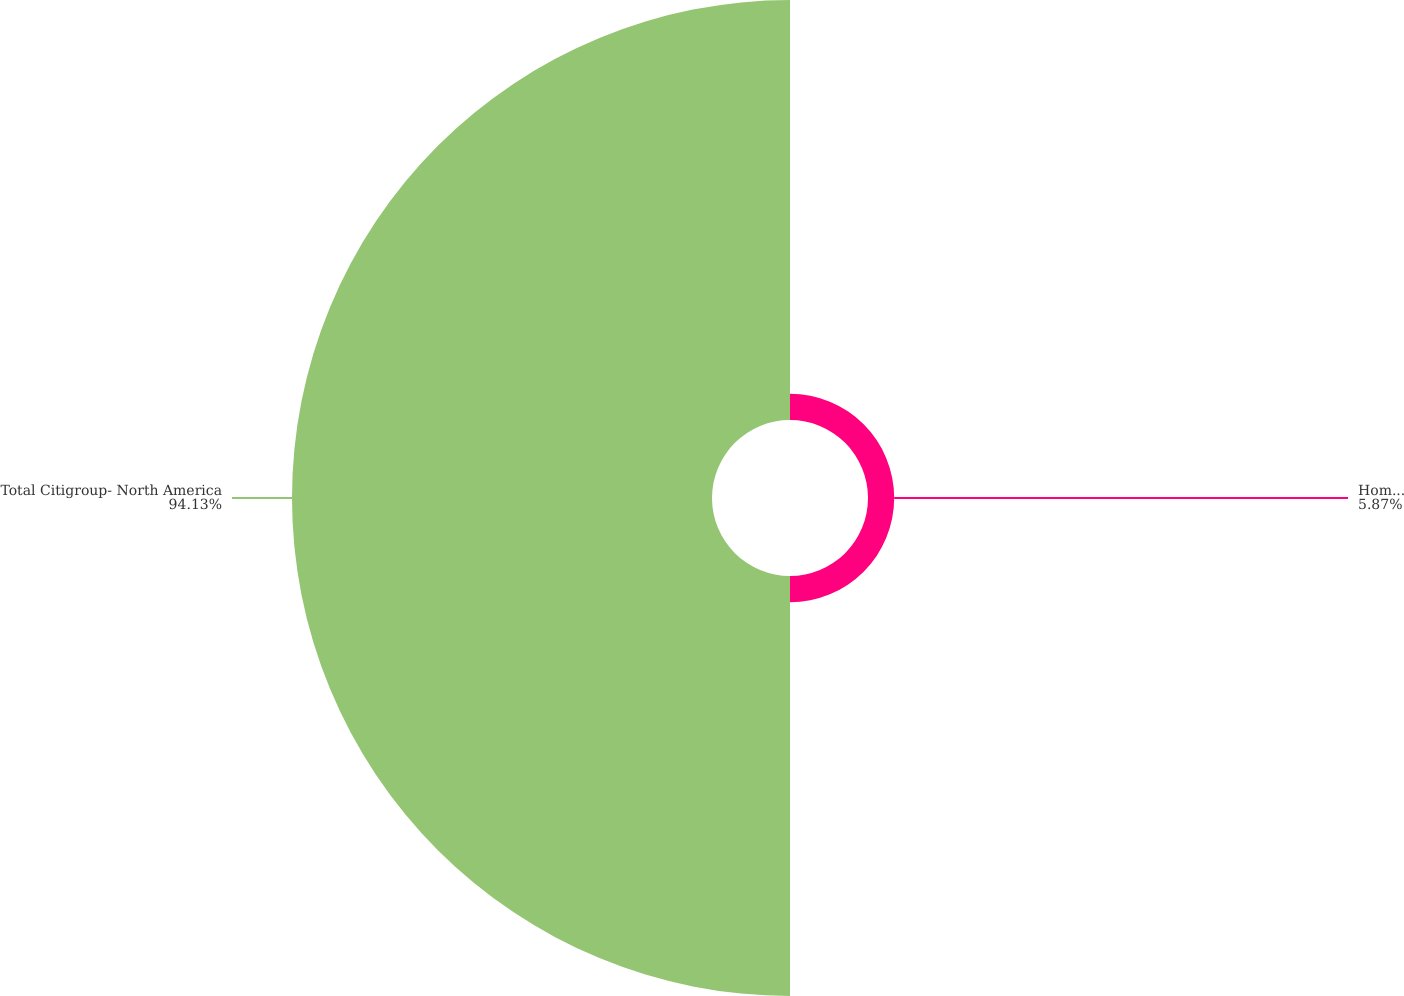<chart> <loc_0><loc_0><loc_500><loc_500><pie_chart><fcel>Home equity<fcel>Total Citigroup- North America<nl><fcel>5.87%<fcel>94.13%<nl></chart> 